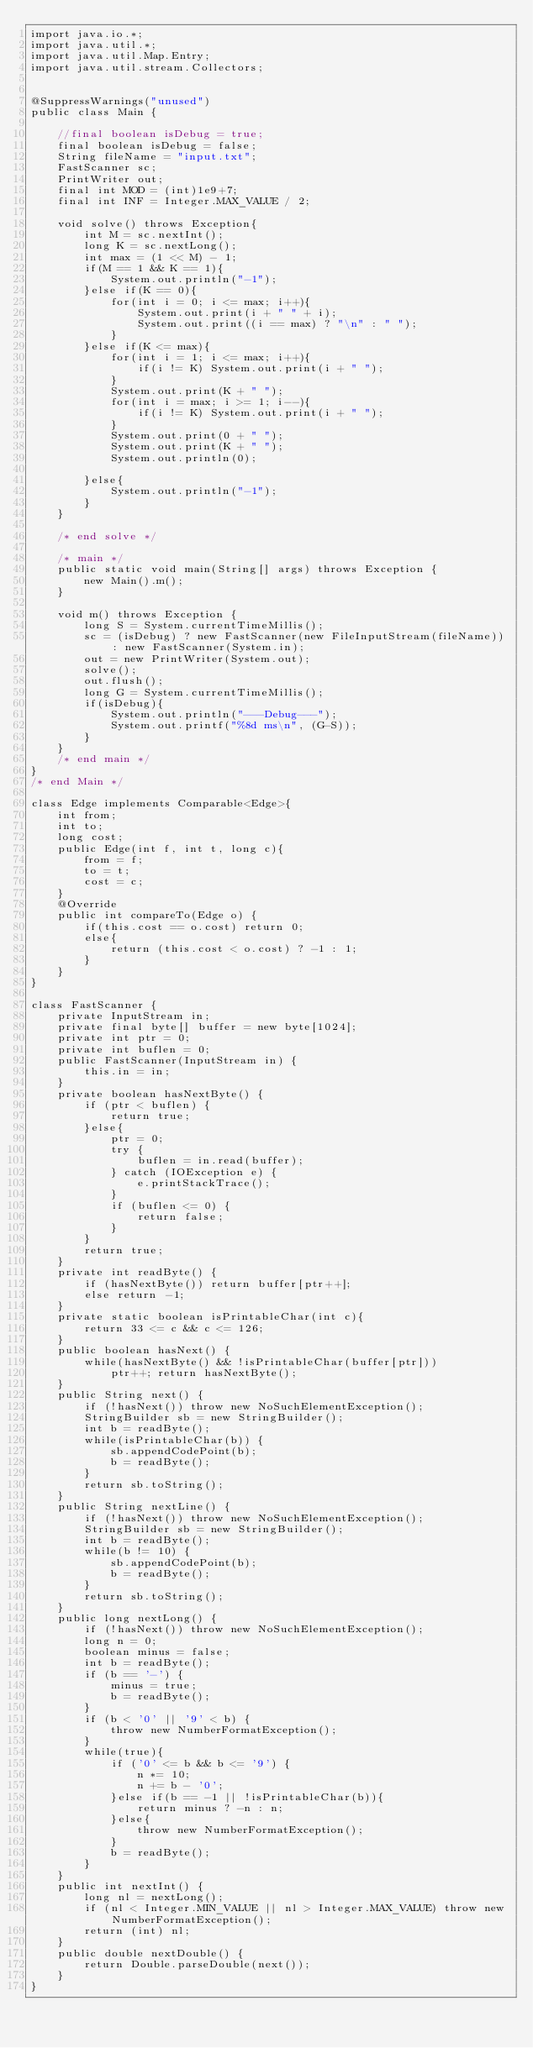Convert code to text. <code><loc_0><loc_0><loc_500><loc_500><_Java_>import java.io.*;
import java.util.*;
import java.util.Map.Entry;
import java.util.stream.Collectors;


@SuppressWarnings("unused")
public class Main {
	
	//final boolean isDebug = true;
	final boolean isDebug = false;
	String fileName = "input.txt";
	FastScanner sc;
	PrintWriter out;
	final int MOD = (int)1e9+7;
	final int INF = Integer.MAX_VALUE / 2;
	
	void solve() throws Exception{
		int M = sc.nextInt();
		long K = sc.nextLong();
		int max = (1 << M) - 1;
		if(M == 1 && K == 1){
			System.out.println("-1");
		}else if(K == 0){
			for(int i = 0; i <= max; i++){
				System.out.print(i + " " + i);
				System.out.print((i == max) ? "\n" : " ");
			}
		}else if(K <= max){
			for(int i = 1; i <= max; i++){
				if(i != K) System.out.print(i + " ");
			}
			System.out.print(K + " ");
			for(int i = max; i >= 1; i--){
				if(i != K) System.out.print(i + " ");
			}
			System.out.print(0 + " ");
			System.out.print(K + " ");
			System.out.println(0);
			
		}else{
			System.out.println("-1");
		}
	}
	
	/* end solve */
	
	/* main */
	public static void main(String[] args) throws Exception {
		new Main().m();
	}
	
	void m() throws Exception {
		long S = System.currentTimeMillis();
		sc = (isDebug) ? new FastScanner(new FileInputStream(fileName)) : new FastScanner(System.in);
		out = new PrintWriter(System.out);
		solve();
		out.flush();
		long G = System.currentTimeMillis();
		if(isDebug){
			System.out.println("---Debug---");
			System.out.printf("%8d ms\n", (G-S));
		}
	}
	/* end main */
}
/* end Main */

class Edge implements Comparable<Edge>{
	int from;
	int to;
	long cost;
	public Edge(int f, int t, long c){
		from = f;
		to = t;
		cost = c;
	}
	@Override
	public int compareTo(Edge o) {
		if(this.cost == o.cost) return 0;
		else{
			return (this.cost < o.cost) ? -1 : 1;
		}
	}
}

class FastScanner {
    private InputStream in;
    private final byte[] buffer = new byte[1024];
    private int ptr = 0;
    private int buflen = 0;
    public FastScanner(InputStream in) {
		this.in = in;
	}
    private boolean hasNextByte() {
        if (ptr < buflen) {
            return true;
        }else{
            ptr = 0;
            try {
                buflen = in.read(buffer);
            } catch (IOException e) {
                e.printStackTrace();
            }
            if (buflen <= 0) {
                return false;
            }
        }
        return true;
    }
    private int readByte() {
    	if (hasNextByte()) return buffer[ptr++];
    	else return -1;
    }
    private static boolean isPrintableChar(int c){
    	return 33 <= c && c <= 126;
    }
    public boolean hasNext() {
    	while(hasNextByte() && !isPrintableChar(buffer[ptr]))
    		ptr++; return hasNextByte();
    }
    public String next() {
        if (!hasNext()) throw new NoSuchElementException();
        StringBuilder sb = new StringBuilder();
        int b = readByte();
        while(isPrintableChar(b)) {
            sb.appendCodePoint(b);
            b = readByte();
        }
        return sb.toString();
    }
    public String nextLine() {
        if (!hasNext()) throw new NoSuchElementException();
        StringBuilder sb = new StringBuilder();
        int b = readByte();
        while(b != 10) {
            sb.appendCodePoint(b);
            b = readByte();
        }
        return sb.toString();
    }
    public long nextLong() {
        if (!hasNext()) throw new NoSuchElementException();
        long n = 0;
        boolean minus = false;
        int b = readByte();
        if (b == '-') {
            minus = true;
            b = readByte();
        }
        if (b < '0' || '9' < b) {
            throw new NumberFormatException();
        }
        while(true){
            if ('0' <= b && b <= '9') {
                n *= 10;
                n += b - '0';
            }else if(b == -1 || !isPrintableChar(b)){
                return minus ? -n : n;
            }else{
                throw new NumberFormatException();
            }
            b = readByte();
        }
    }
    public int nextInt() {
        long nl = nextLong();
        if (nl < Integer.MIN_VALUE || nl > Integer.MAX_VALUE) throw new NumberFormatException();
        return (int) nl;
    }
    public double nextDouble() {
    	return Double.parseDouble(next());
    }
}</code> 